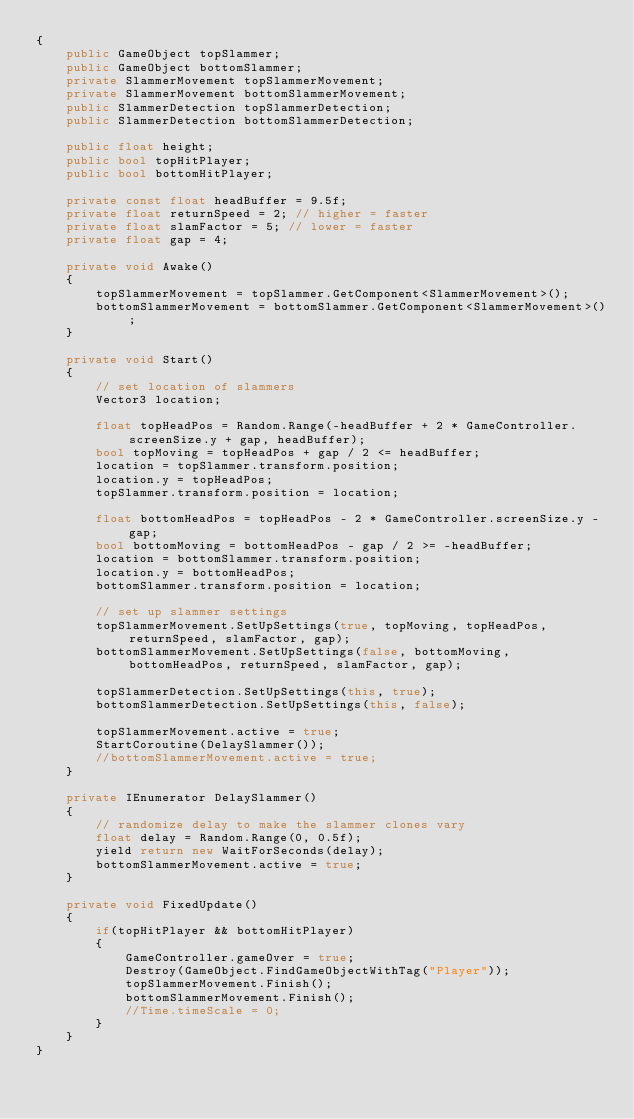Convert code to text. <code><loc_0><loc_0><loc_500><loc_500><_C#_>{
    public GameObject topSlammer;
    public GameObject bottomSlammer;
    private SlammerMovement topSlammerMovement;
    private SlammerMovement bottomSlammerMovement;
    public SlammerDetection topSlammerDetection;
    public SlammerDetection bottomSlammerDetection;

    public float height;
    public bool topHitPlayer;
    public bool bottomHitPlayer;

    private const float headBuffer = 9.5f;
    private float returnSpeed = 2; // higher = faster
    private float slamFactor = 5; // lower = faster
    private float gap = 4;

    private void Awake()
    {
        topSlammerMovement = topSlammer.GetComponent<SlammerMovement>();
        bottomSlammerMovement = bottomSlammer.GetComponent<SlammerMovement>();
    }

    private void Start()
    {
        // set location of slammers
        Vector3 location;

        float topHeadPos = Random.Range(-headBuffer + 2 * GameController.screenSize.y + gap, headBuffer);
        bool topMoving = topHeadPos + gap / 2 <= headBuffer;
        location = topSlammer.transform.position;
        location.y = topHeadPos;
        topSlammer.transform.position = location;

        float bottomHeadPos = topHeadPos - 2 * GameController.screenSize.y - gap;
        bool bottomMoving = bottomHeadPos - gap / 2 >= -headBuffer;
        location = bottomSlammer.transform.position;
        location.y = bottomHeadPos;
        bottomSlammer.transform.position = location;

        // set up slammer settings
        topSlammerMovement.SetUpSettings(true, topMoving, topHeadPos, returnSpeed, slamFactor, gap);
        bottomSlammerMovement.SetUpSettings(false, bottomMoving, bottomHeadPos, returnSpeed, slamFactor, gap);

        topSlammerDetection.SetUpSettings(this, true);
        bottomSlammerDetection.SetUpSettings(this, false);

        topSlammerMovement.active = true;
        StartCoroutine(DelaySlammer());
        //bottomSlammerMovement.active = true;
    }

    private IEnumerator DelaySlammer()
    {
        // randomize delay to make the slammer clones vary
        float delay = Random.Range(0, 0.5f);
        yield return new WaitForSeconds(delay);
        bottomSlammerMovement.active = true;
    }

    private void FixedUpdate()
    {
        if(topHitPlayer && bottomHitPlayer)
        {
            GameController.gameOver = true;
            Destroy(GameObject.FindGameObjectWithTag("Player"));
            topSlammerMovement.Finish();
            bottomSlammerMovement.Finish();
            //Time.timeScale = 0;
        }
    }
}

</code> 